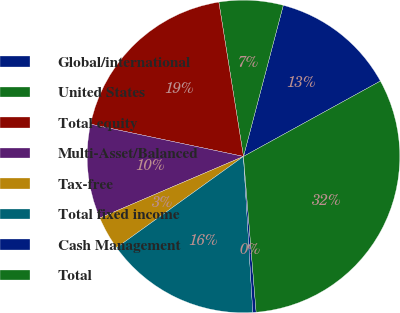<chart> <loc_0><loc_0><loc_500><loc_500><pie_chart><fcel>Global/international<fcel>United States<fcel>Total equity<fcel>Multi-Asset/Balanced<fcel>Tax-free<fcel>Total fixed income<fcel>Cash Management<fcel>Total<nl><fcel>12.89%<fcel>6.62%<fcel>19.17%<fcel>9.75%<fcel>3.48%<fcel>16.03%<fcel>0.34%<fcel>31.72%<nl></chart> 